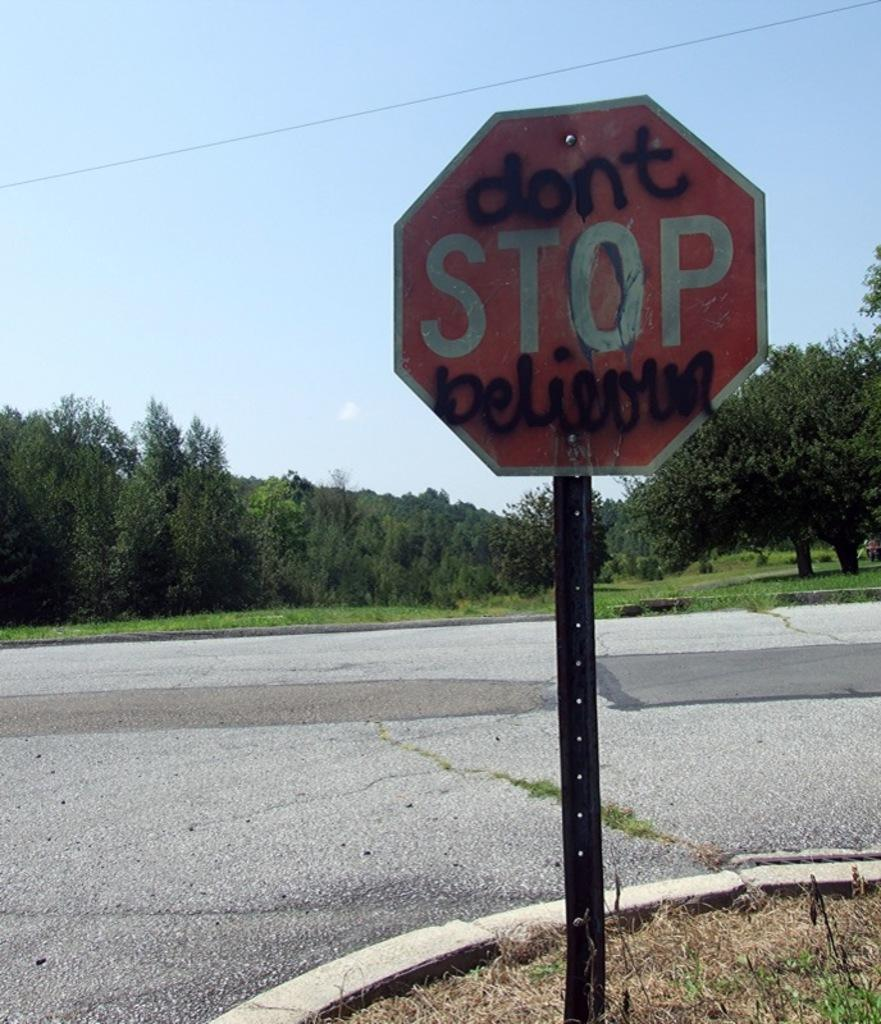<image>
Describe the image concisely. a graffitti filled stop sign that says "don't stop believing". 